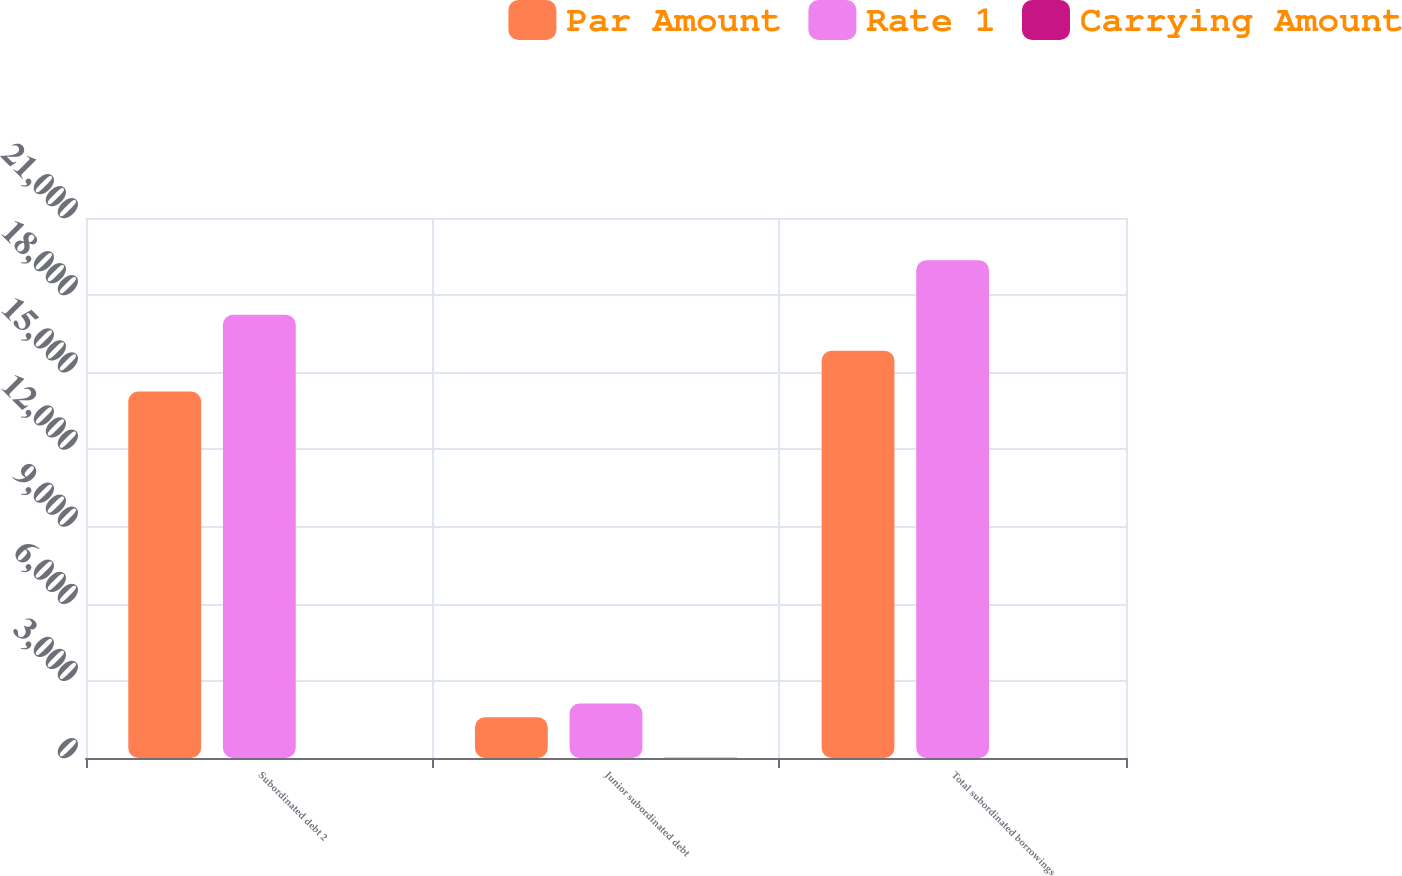Convert chart. <chart><loc_0><loc_0><loc_500><loc_500><stacked_bar_chart><ecel><fcel>Subordinated debt 2<fcel>Junior subordinated debt<fcel>Total subordinated borrowings<nl><fcel>Par Amount<fcel>14254<fcel>1582<fcel>15836<nl><fcel>Rate 1<fcel>17236<fcel>2121<fcel>19357<nl><fcel>Carrying Amount<fcel>3.77<fcel>6.21<fcel>4.02<nl></chart> 